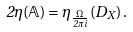Convert formula to latex. <formula><loc_0><loc_0><loc_500><loc_500>2 \eta ( \mathbb { A } ) = \eta _ { \frac { \Omega } { 2 \pi i } } ( D _ { X } ) \, .</formula> 